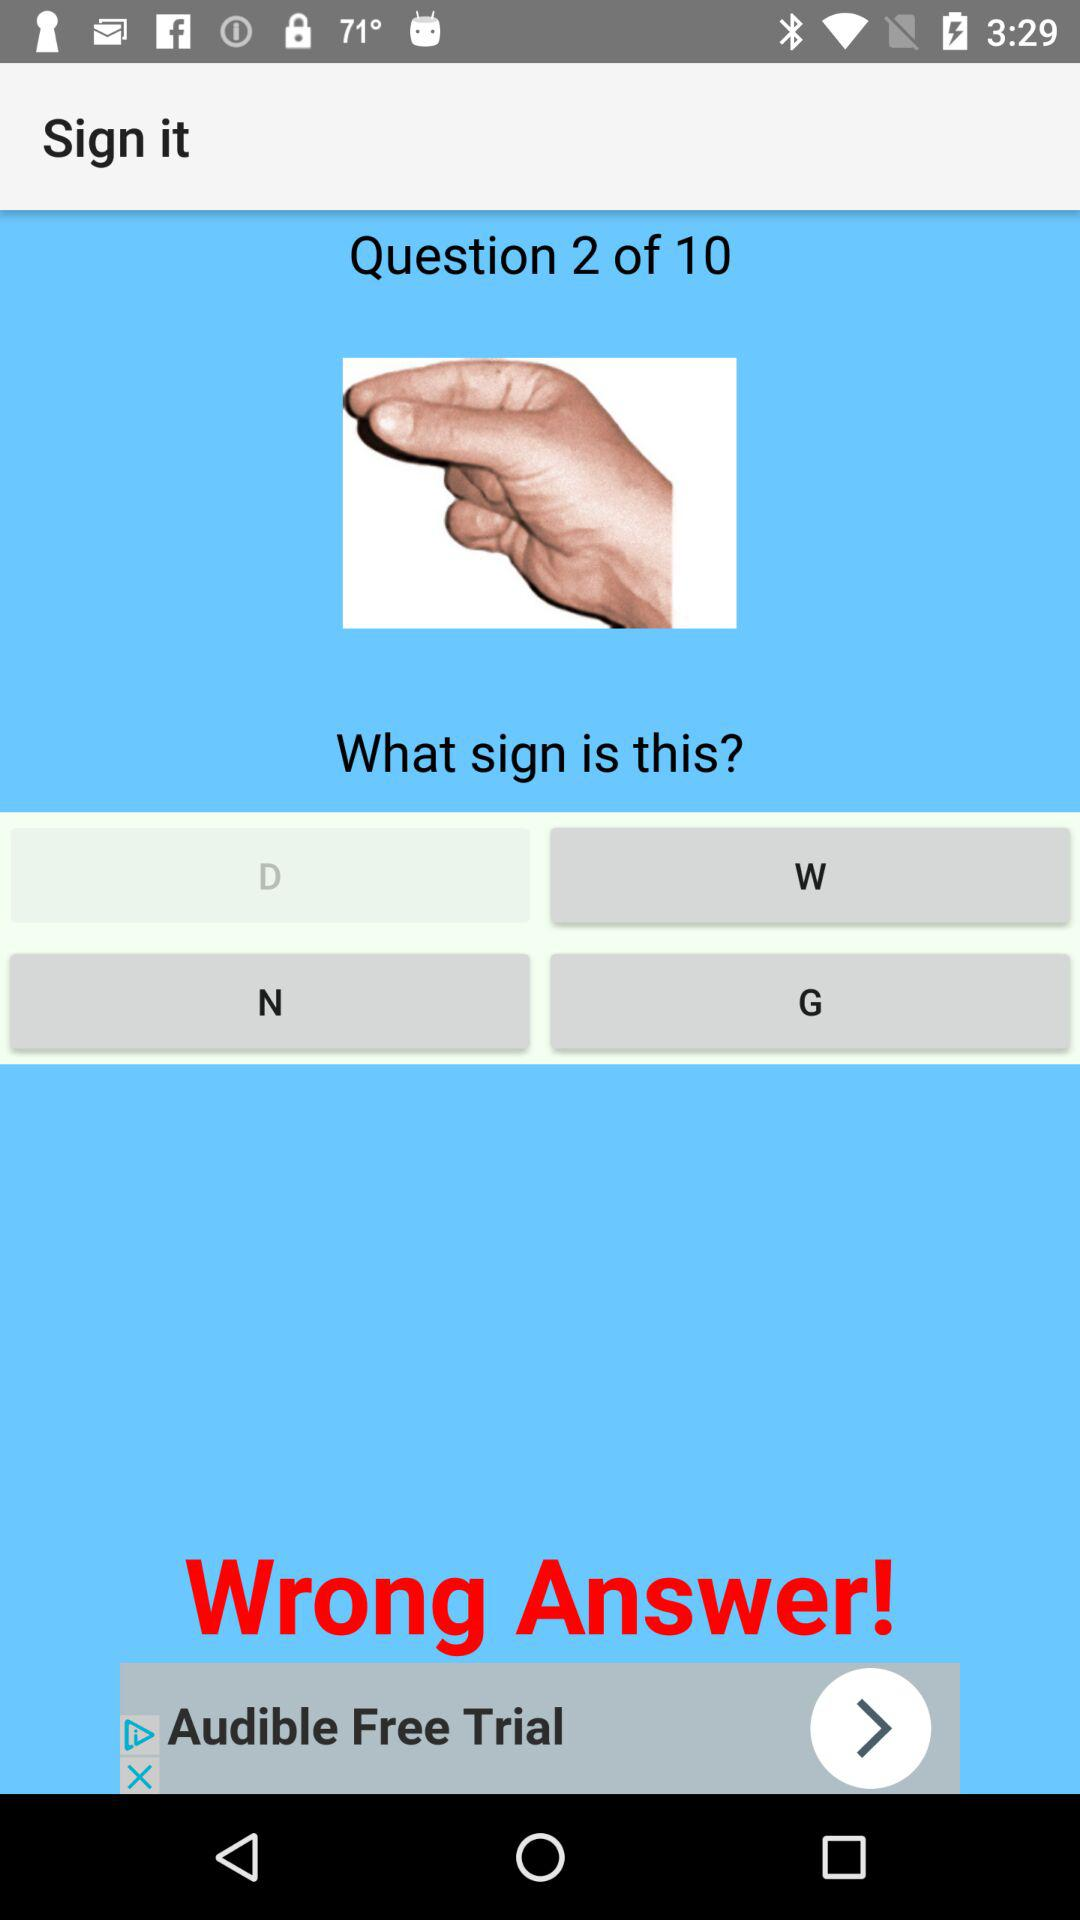How many questions in total are there? There are 10 questions in total. 